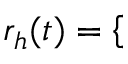<formula> <loc_0><loc_0><loc_500><loc_500>r _ { h } ( t ) = \left \{ \begin{array} { r l r } \end{array}</formula> 